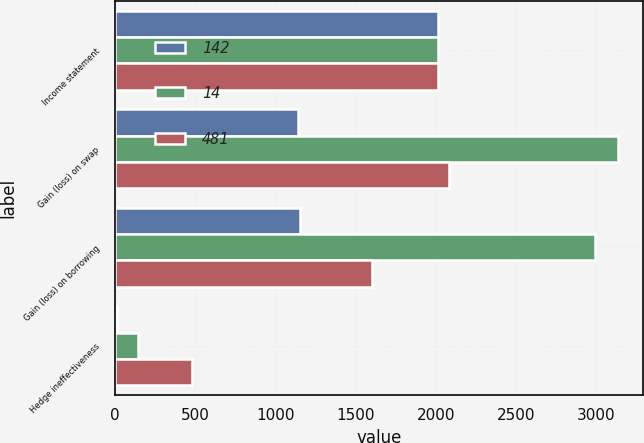Convert chart. <chart><loc_0><loc_0><loc_500><loc_500><stacked_bar_chart><ecel><fcel>Income statement<fcel>Gain (loss) on swap<fcel>Gain (loss) on borrowing<fcel>Hedge ineffectiveness<nl><fcel>142<fcel>2014<fcel>1140<fcel>1154<fcel>14<nl><fcel>14<fcel>2013<fcel>3133<fcel>2991<fcel>142<nl><fcel>481<fcel>2012<fcel>2085<fcel>1604<fcel>481<nl></chart> 